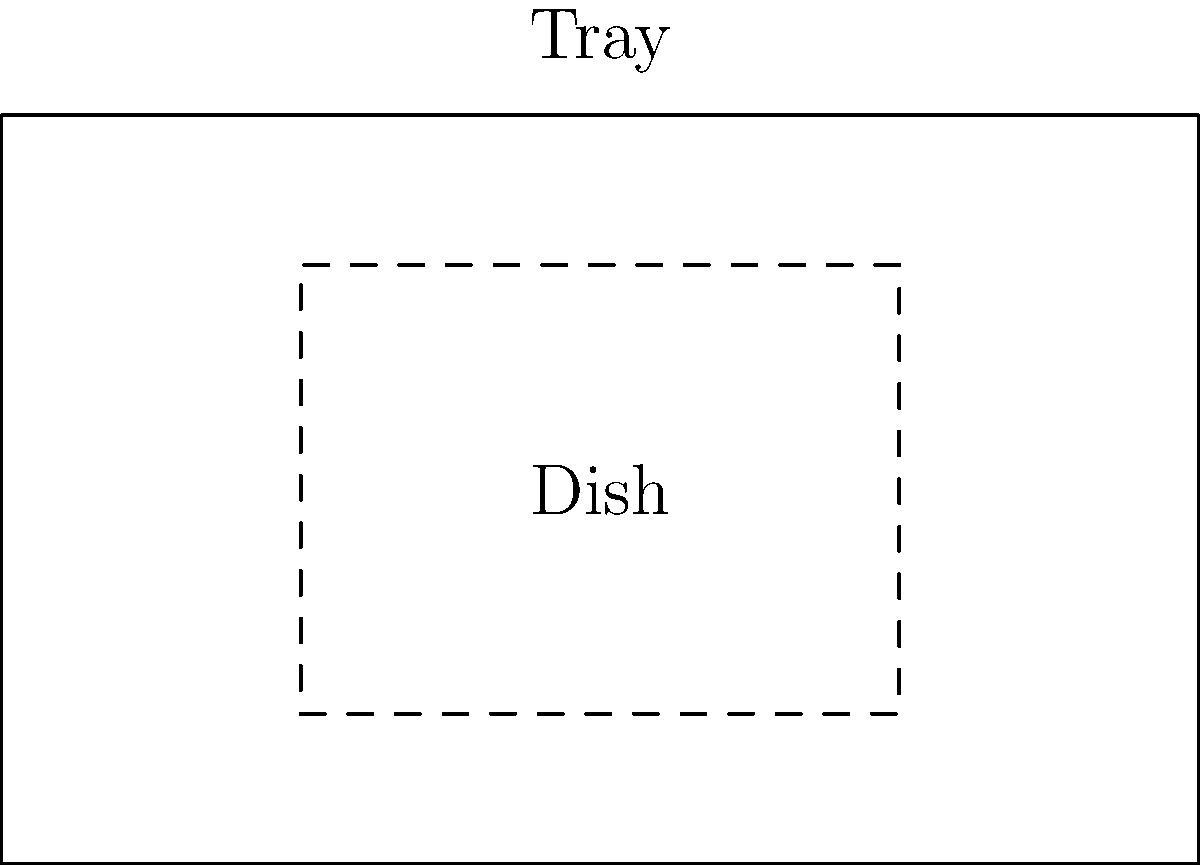As an innovative pub chef, you're designing a new serving tray for your latest dish creation. The rectangular tray measures 8 inches by 5 inches, and you want to maximize the number of identical rectangular dishes that can fit on it. Each dish measures 4 inches by 3 inches. What is the maximum number of dishes that can fit on the tray without overlapping? Let's approach this step-by-step:

1) First, we need to determine the possible orientations of the dishes on the tray:
   - Orientation 1: 4 inches along the length, 3 inches along the width
   - Orientation 2: 3 inches along the length, 4 inches along the width

2) Let's calculate how many dishes can fit in each orientation:

   Orientation 1:
   - Along the length: $\lfloor \frac{8}{4} \rfloor = 2$ dishes
   - Along the width: $\lfloor \frac{5}{3} \rfloor = 1$ dish
   - Total: $2 \times 1 = 2$ dishes

   Orientation 2:
   - Along the length: $\lfloor \frac{8}{3} \rfloor = 2$ dishes
   - Along the width: $\lfloor \frac{5}{4} \rfloor = 1$ dish
   - Total: $2 \times 1 = 2$ dishes

3) Both orientations yield the same result: 2 dishes.

Therefore, the maximum number of dishes that can fit on the tray without overlapping is 2.
Answer: 2 dishes 